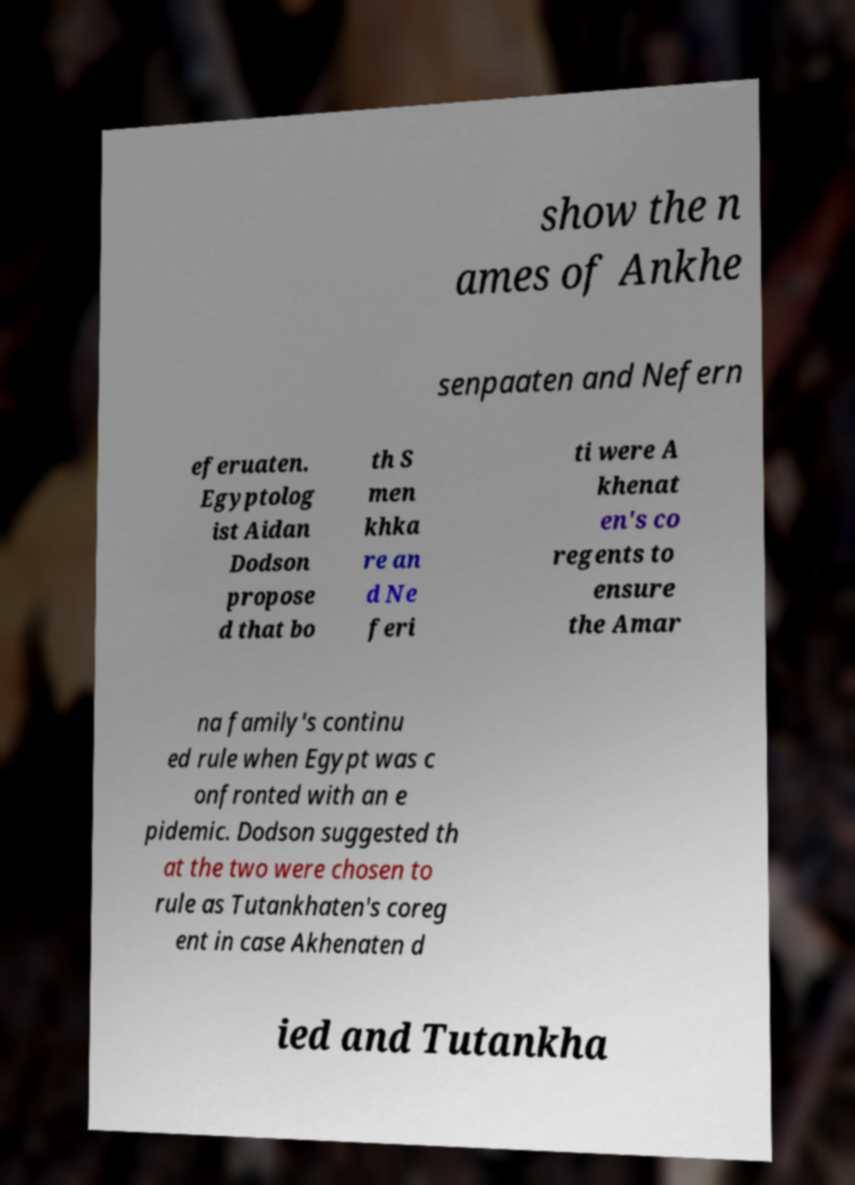Could you assist in decoding the text presented in this image and type it out clearly? show the n ames of Ankhe senpaaten and Nefern eferuaten. Egyptolog ist Aidan Dodson propose d that bo th S men khka re an d Ne feri ti were A khenat en's co regents to ensure the Amar na family's continu ed rule when Egypt was c onfronted with an e pidemic. Dodson suggested th at the two were chosen to rule as Tutankhaten's coreg ent in case Akhenaten d ied and Tutankha 